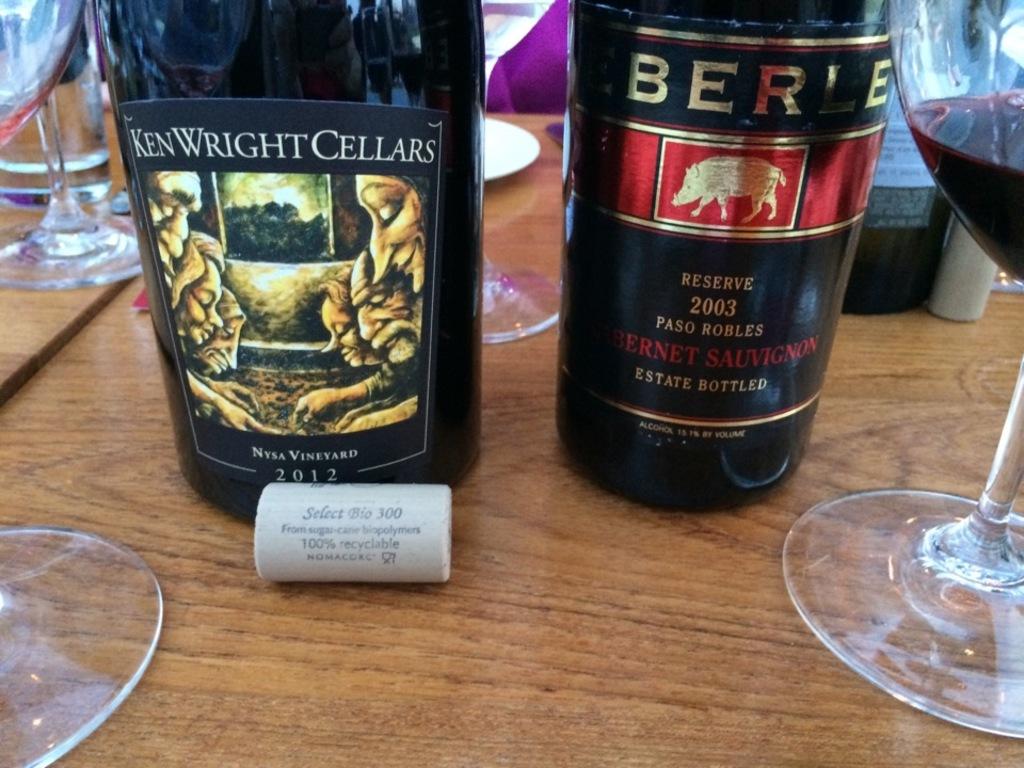What kind if wine is this?
Ensure brevity in your answer.  Cabernet sauvignon. 